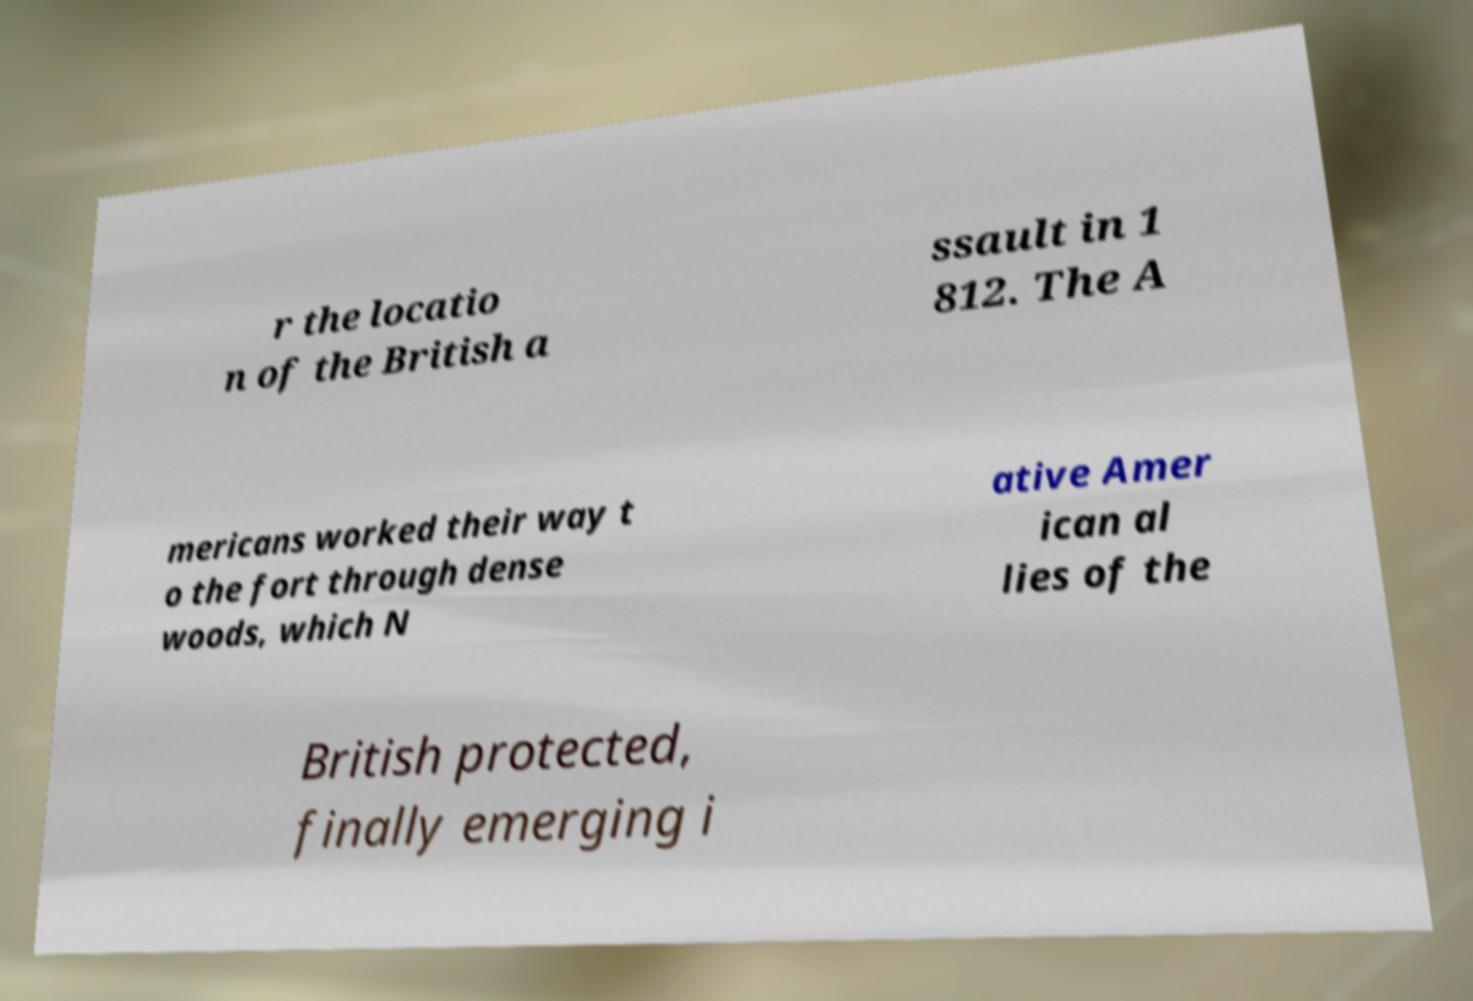What messages or text are displayed in this image? I need them in a readable, typed format. r the locatio n of the British a ssault in 1 812. The A mericans worked their way t o the fort through dense woods, which N ative Amer ican al lies of the British protected, finally emerging i 